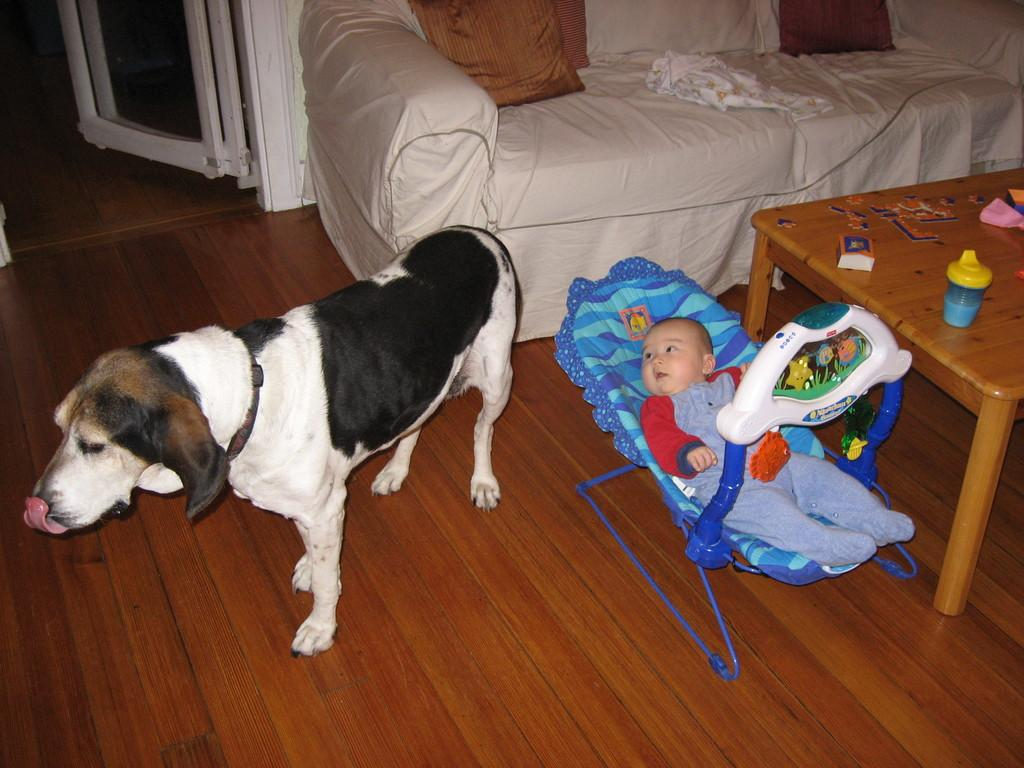What type of animal can be seen in the image? There is a dog in the image. What is the baby in the image sitting in? The baby is in a stroller in the image. What object is related to feeding in the image? There is a bottle in the image. What piece of furniture is present in the image? There is a couch in the image. What is the baby covered with in the image? There is a blanket in the image. What is on the table in the image? There is a box on a table in the image. What is used for comfort while sitting or lying down in the image? There is a pillow in the image. What feature allows access to different areas in the image? There is a door in the image. Can you describe the fight between the man and the dog in the image? There is no man or fight present in the image; it features a dog, a baby in a stroller, a bottle, a box on a table, a couch, a blanket, a pillow, and a door. 